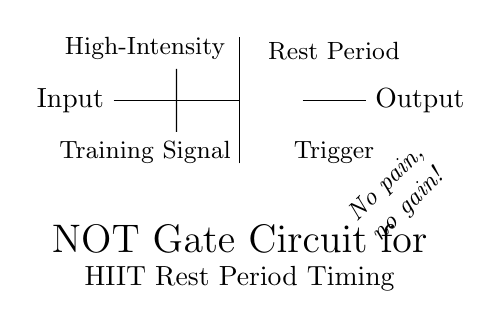What is the output of the NOT gate when the input is high? The NOT gate inverts the input signal. If the input is high, the output will be low.
Answer: Low What component is used to indicate the timing system response? The NOT gate is the component responsible for inverting the input signal to determine the timing response for rest periods.
Answer: NOT gate What does the input signal represent in this circuit? The input signal represents the high-intensity training signal, which indicates when the high-intensity exercise is occurring.
Answer: High-Intensity Training Signal What happens to the output when the input goes low? When the input goes low, the NOT gate will invert the signal, resulting in the output going high, which triggers the rest period.
Answer: High What is the function of the circuit in one phrase? The function of the circuit is to manage rest periods during high-intensity interval training by inverting the training signal.
Answer: Timing system for rest periods How would you describe the relationship between the input and output? The relationship is such that the output is the inverse of the input; an active input leads to an inactive output and vice versa.
Answer: Inverse relationship 